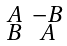Convert formula to latex. <formula><loc_0><loc_0><loc_500><loc_500>\begin{smallmatrix} A & - B \\ B & A \end{smallmatrix}</formula> 